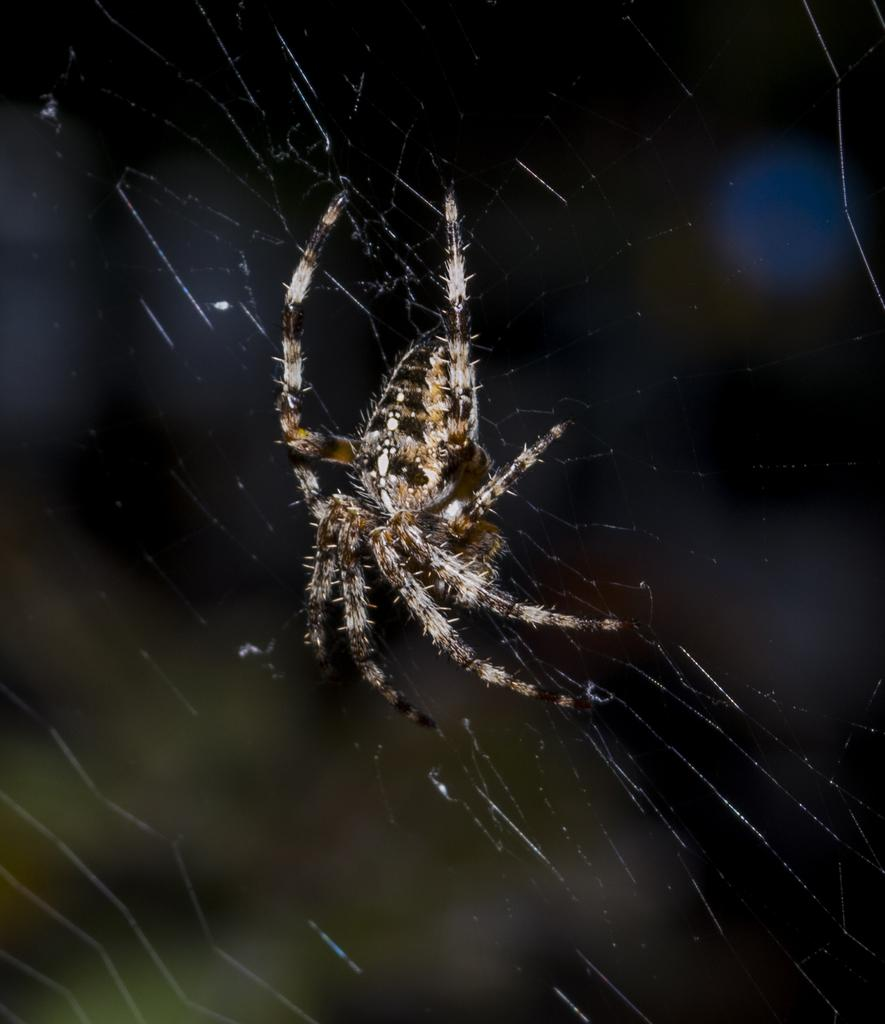What is the main subject of the image? The main subject of the image is a spider. Where is the spider located in the image? The spider is on a spider web. Can you describe the background of the image? There is something behind the spider, but it is not clearly visible. What type of cake is being served at the spider's birthday party in the image? There is no cake or birthday party present in the image; it features a spider on a spider web. How does the zephyr affect the spider's web in the image? There is no mention of a zephyr or any wind in the image; it only shows a spider on a spider web. 